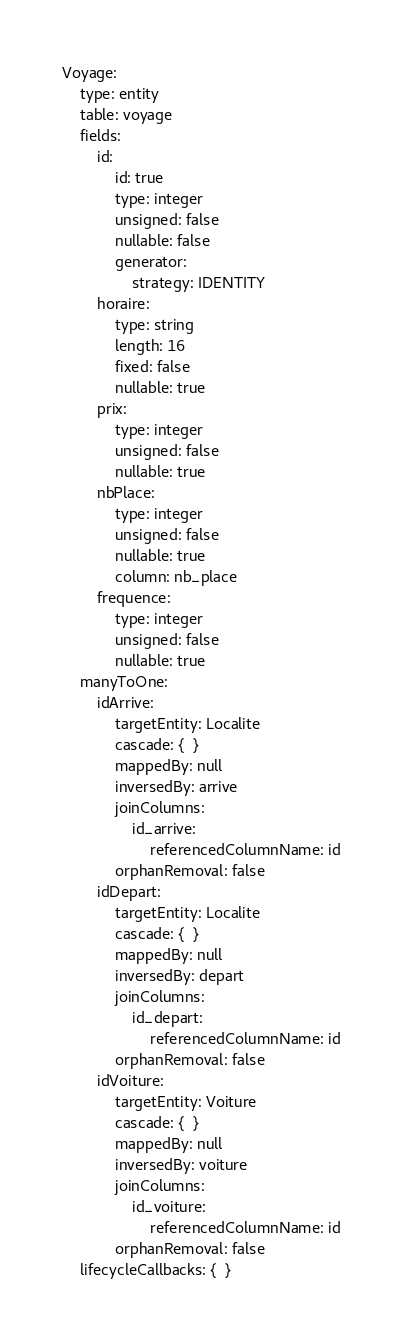Convert code to text. <code><loc_0><loc_0><loc_500><loc_500><_YAML_>Voyage:
    type: entity
    table: voyage
    fields:
        id:
            id: true
            type: integer
            unsigned: false
            nullable: false
            generator:
                strategy: IDENTITY
        horaire:
            type: string
            length: 16
            fixed: false
            nullable: true
        prix:
            type: integer
            unsigned: false
            nullable: true
        nbPlace:
            type: integer
            unsigned: false
            nullable: true
            column: nb_place
        frequence:
            type: integer
            unsigned: false
            nullable: true
    manyToOne:
        idArrive:
            targetEntity: Localite
            cascade: {  }
            mappedBy: null
            inversedBy: arrive
            joinColumns:
                id_arrive:
                    referencedColumnName: id
            orphanRemoval: false
        idDepart:
            targetEntity: Localite
            cascade: {  }
            mappedBy: null
            inversedBy: depart
            joinColumns:
                id_depart:
                    referencedColumnName: id
            orphanRemoval: false
        idVoiture:
            targetEntity: Voiture
            cascade: {  }
            mappedBy: null
            inversedBy: voiture
            joinColumns:
                id_voiture:
                    referencedColumnName: id
            orphanRemoval: false
    lifecycleCallbacks: {  }
</code> 